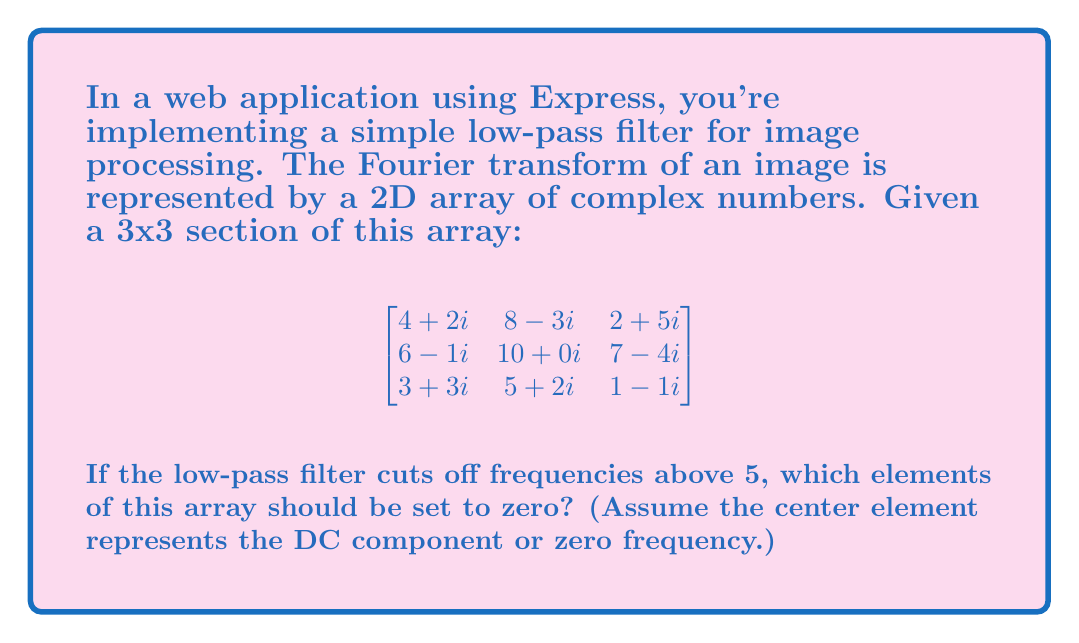Could you help me with this problem? To solve this problem, we need to understand how a low-pass filter works in the frequency domain and how it applies to the Fourier transform of an image. Let's break it down step-by-step:

1) In a 2D Fourier transform, the center element represents the DC component (zero frequency). The further an element is from the center, the higher frequency it represents.

2) A low-pass filter with a cutoff frequency of 5 means we keep all frequencies below 5 and remove (set to zero) all frequencies above 5.

3) To determine which elements to keep, we need to calculate the distance of each element from the center. In this 3x3 matrix, the center element is at position (1,1) (using 0-based indexing).

4) The distance can be calculated using the Euclidean distance formula:
   $$d = \sqrt{(x-x_c)^2 + (y-y_c)^2}$$
   where $(x_c, y_c)$ is the center position (1,1).

5) Let's calculate the distance for each element:
   - (0,0): $d = \sqrt{(0-1)^2 + (0-1)^2} = \sqrt{2} \approx 1.41$
   - (0,1): $d = \sqrt{(0-1)^2 + (1-1)^2} = 1$
   - (0,2): $d = \sqrt{(0-1)^2 + (2-1)^2} = \sqrt{2} \approx 1.41$
   - (1,0): $d = \sqrt{(1-1)^2 + (0-1)^2} = 1$
   - (1,1): $d = \sqrt{(1-1)^2 + (1-1)^2} = 0$
   - (1,2): $d = \sqrt{(1-1)^2 + (2-1)^2} = 1$
   - (2,0): $d = \sqrt{(2-1)^2 + (0-1)^2} = \sqrt{2} \approx 1.41$
   - (2,1): $d = \sqrt{(2-1)^2 + (1-1)^2} = 1$
   - (2,2): $d = \sqrt{(2-1)^2 + (2-1)^2} = \sqrt{2} \approx 1.41$

6) Since all distances are less than 5, no elements need to be set to zero in this case.
Answer: No elements need to be set to zero. 